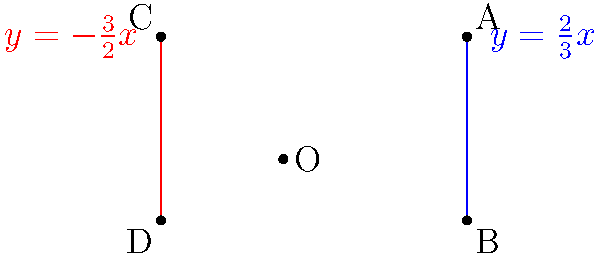Hey, it's been a while since we last caught up! I remember you were always great at math, especially geometry. I came across this problem and thought of you. Can you help me find the angle between these two lines? The blue line has a slope of $\frac{2}{3}$, and the red line has a slope of $-\frac{3}{2}$. How would you calculate the angle between them? Sure, I'd be happy to help! Let's solve this step-by-step:

1) The formula for finding the angle $\theta$ between two lines with slopes $m_1$ and $m_2$ is:

   $$\tan \theta = \left|\frac{m_2 - m_1}{1 + m_1m_2}\right|$$

2) In this case, $m_1 = \frac{2}{3}$ (blue line) and $m_2 = -\frac{3}{2}$ (red line).

3) Let's substitute these values into the formula:

   $$\tan \theta = \left|\frac{-\frac{3}{2} - \frac{2}{3}}{1 + (\frac{2}{3})(-\frac{3}{2})}\right|$$

4) Simplify the numerator:
   $$-\frac{3}{2} - \frac{2}{3} = -\frac{9}{6} - \frac{4}{6} = -\frac{13}{6}$$

5) Simplify the denominator:
   $$1 + (\frac{2}{3})(-\frac{3}{2}) = 1 - 1 = 0$$

6) Our equation now looks like:

   $$\tan \theta = \left|\frac{-\frac{13}{6}}{0}\right|$$

7) This result indicates that the tangent of the angle is undefined, which occurs when the angle is 90°.

8) This makes sense geometrically, as perpendicular lines have slopes that are negative reciprocals of each other, which is true for $\frac{2}{3}$ and $-\frac{3}{2}$.

Therefore, the angle between these two lines is 90°.
Answer: 90° 